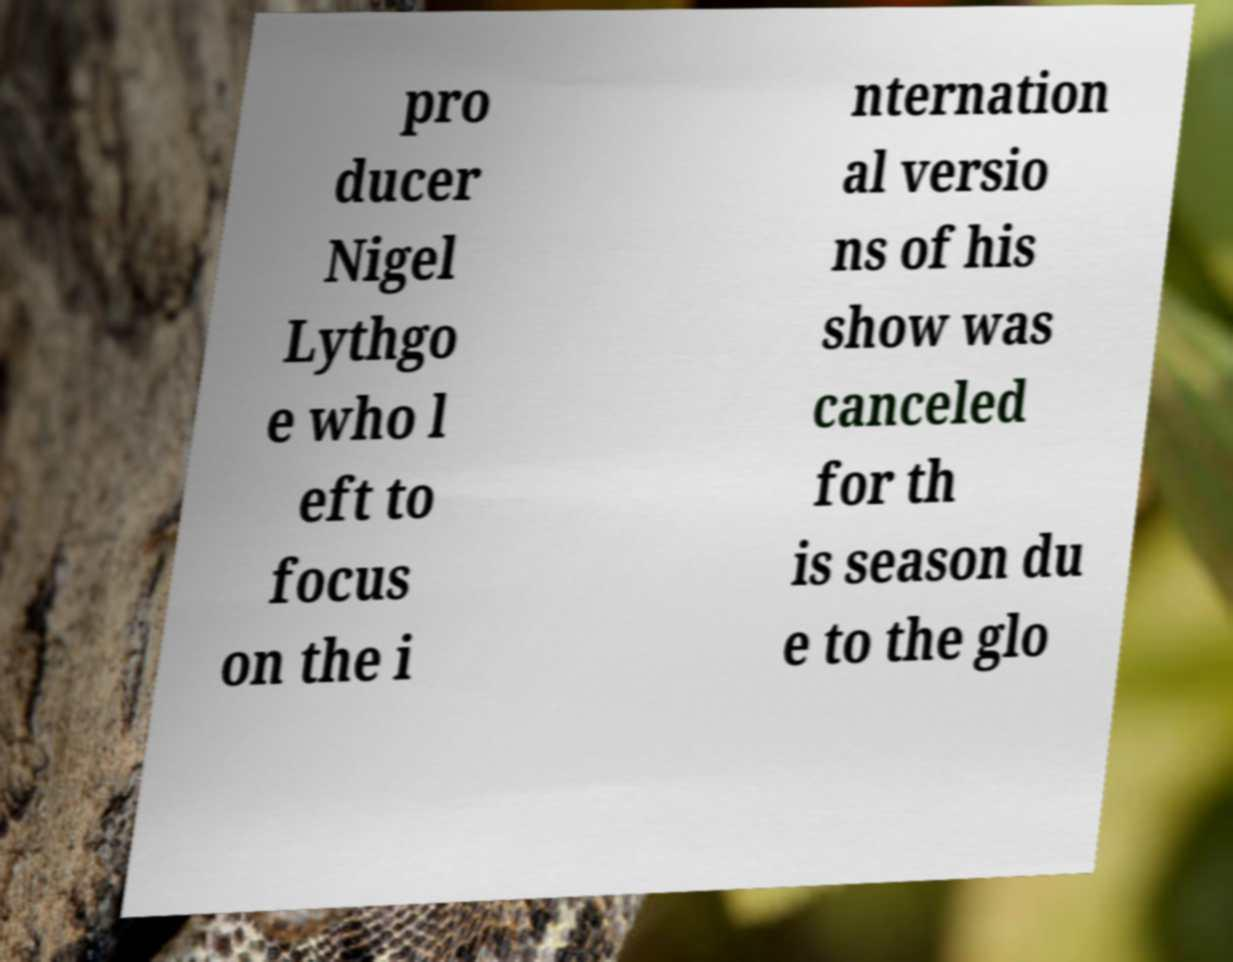Can you read and provide the text displayed in the image?This photo seems to have some interesting text. Can you extract and type it out for me? pro ducer Nigel Lythgo e who l eft to focus on the i nternation al versio ns of his show was canceled for th is season du e to the glo 